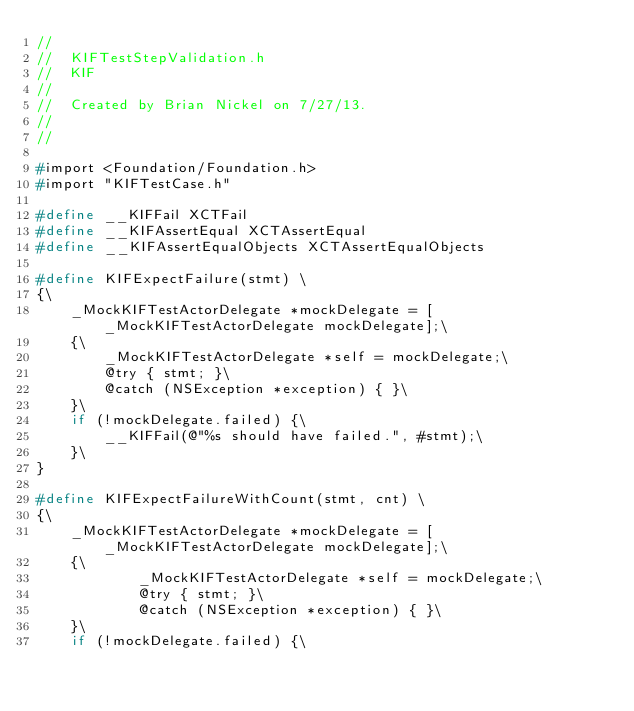Convert code to text. <code><loc_0><loc_0><loc_500><loc_500><_C_>//
//  KIFTestStepValidation.h
//  KIF
//
//  Created by Brian Nickel on 7/27/13.
//
//

#import <Foundation/Foundation.h>
#import "KIFTestCase.h"

#define __KIFFail XCTFail
#define __KIFAssertEqual XCTAssertEqual
#define __KIFAssertEqualObjects XCTAssertEqualObjects

#define KIFExpectFailure(stmt) \
{\
    _MockKIFTestActorDelegate *mockDelegate = [_MockKIFTestActorDelegate mockDelegate];\
    {\
        _MockKIFTestActorDelegate *self = mockDelegate;\
        @try { stmt; }\
        @catch (NSException *exception) { }\
    }\
    if (!mockDelegate.failed) {\
        __KIFFail(@"%s should have failed.", #stmt);\
    }\
}

#define KIFExpectFailureWithCount(stmt, cnt) \
{\
    _MockKIFTestActorDelegate *mockDelegate = [_MockKIFTestActorDelegate mockDelegate];\
    {\
            _MockKIFTestActorDelegate *self = mockDelegate;\
            @try { stmt; }\
            @catch (NSException *exception) { }\
    }\
    if (!mockDelegate.failed) {\</code> 